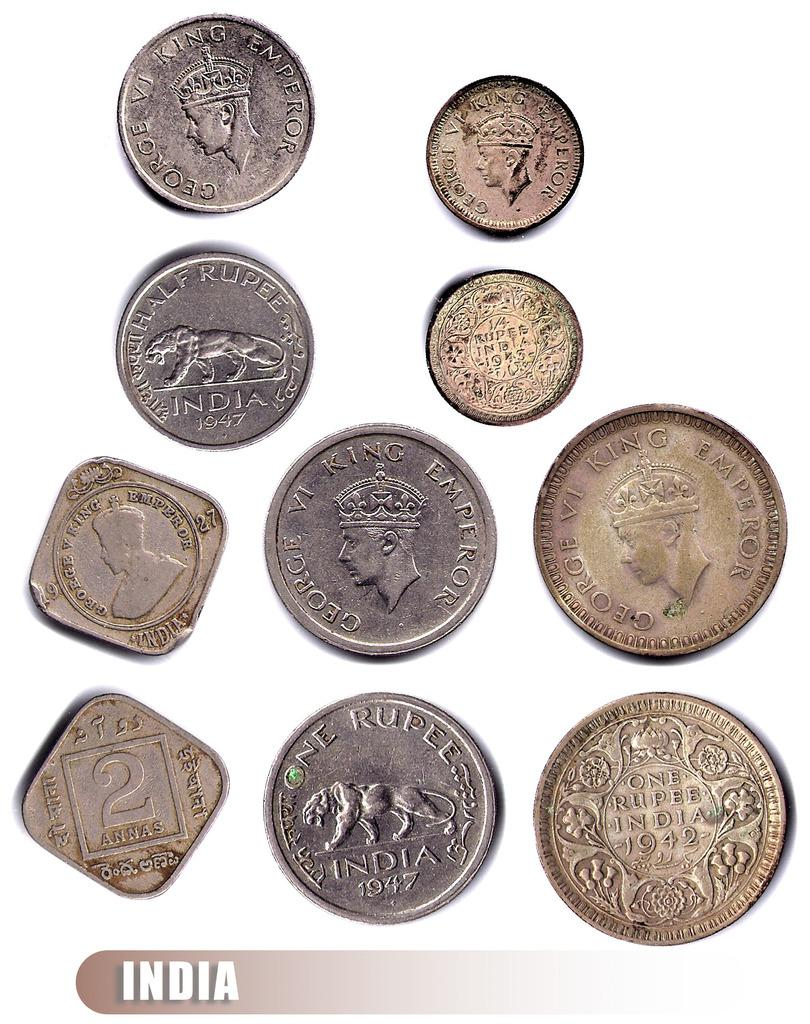<image>
Share a concise interpretation of the image provided. a series of coins on a white surface with one of them that says 'india' 